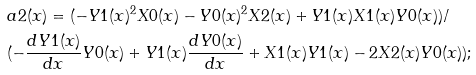<formula> <loc_0><loc_0><loc_500><loc_500>& a 2 ( x ) = ( - Y 1 ( x ) ^ { 2 } X 0 ( x ) - Y 0 ( x ) ^ { 2 } X 2 ( x ) + Y 1 ( x ) X 1 ( x ) Y 0 ( x ) ) / \\ & ( - \frac { d Y 1 ( x ) } { d x } Y 0 ( x ) + Y 1 ( x ) \frac { d Y 0 ( x ) } { d x } + X 1 ( x ) Y 1 ( x ) - 2 X 2 ( x ) Y 0 ( x ) ) ;</formula> 